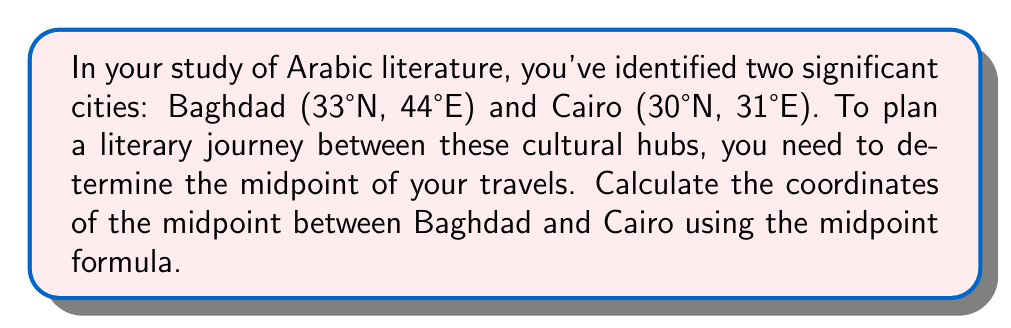Can you answer this question? To find the midpoint between two points in a coordinate system, we use the midpoint formula:

$$ \text{Midpoint} = \left(\frac{x_1 + x_2}{2}, \frac{y_1 + y_2}{2}\right) $$

Where $(x_1, y_1)$ are the coordinates of the first point and $(x_2, y_2)$ are the coordinates of the second point.

In this case:
- Baghdad: $(x_1, y_1) = (44\text{°E}, 33\text{°N})$
- Cairo: $(x_2, y_2) = (31\text{°E}, 30\text{°N})$

Let's substitute these values into the formula:

$$ \text{Midpoint} = \left(\frac{44 + 31}{2}, \frac{33 + 30}{2}\right) $$

Now, let's calculate each coordinate:

For the longitude (x-coordinate):
$$ \frac{44 + 31}{2} = \frac{75}{2} = 37.5\text{°E} $$

For the latitude (y-coordinate):
$$ \frac{33 + 30}{2} = \frac{63}{2} = 31.5\text{°N} $$

Therefore, the midpoint between Baghdad and Cairo is (37.5°E, 31.5°N).
Answer: (37.5°E, 31.5°N) 